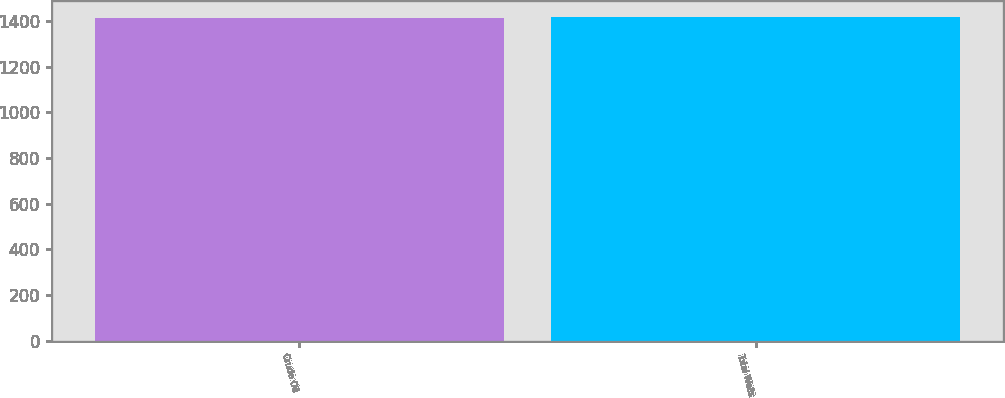<chart> <loc_0><loc_0><loc_500><loc_500><bar_chart><fcel>Crude Oil<fcel>Total Wells<nl><fcel>1415<fcel>1417<nl></chart> 